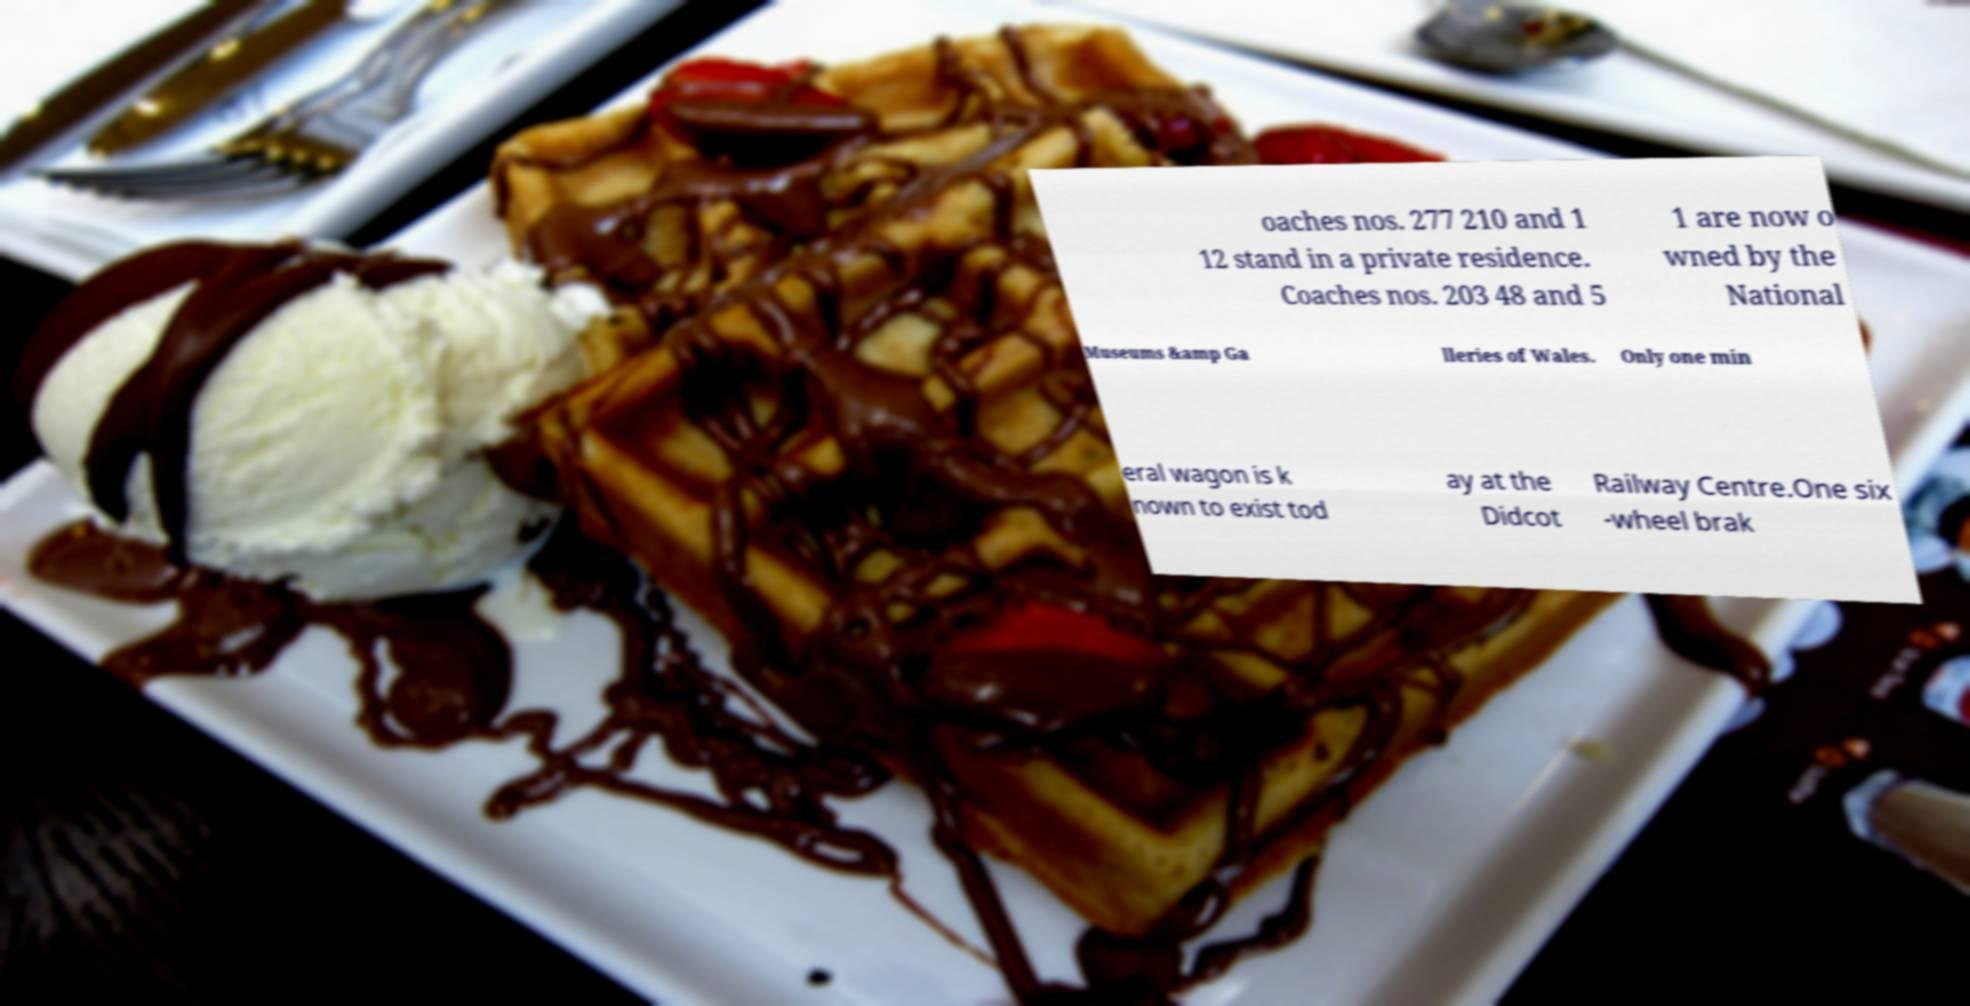Can you read and provide the text displayed in the image?This photo seems to have some interesting text. Can you extract and type it out for me? oaches nos. 277 210 and 1 12 stand in a private residence. Coaches nos. 203 48 and 5 1 are now o wned by the National Museums &amp Ga lleries of Wales. Only one min eral wagon is k nown to exist tod ay at the Didcot Railway Centre.One six -wheel brak 